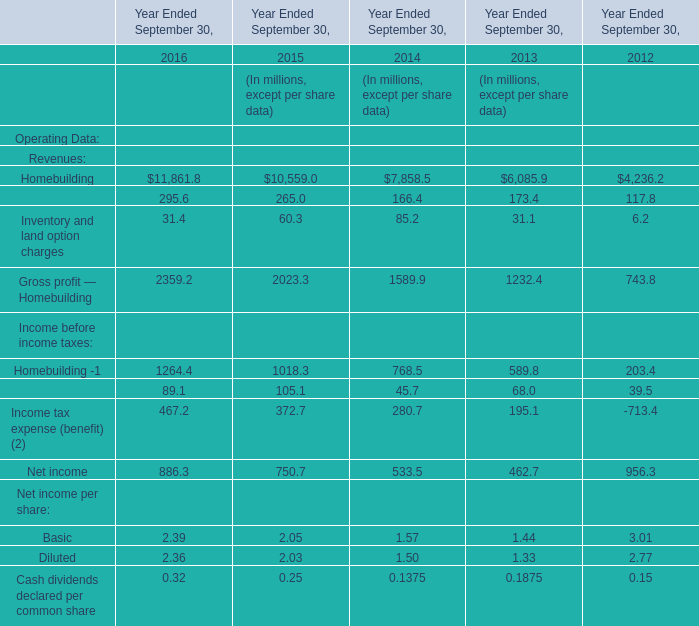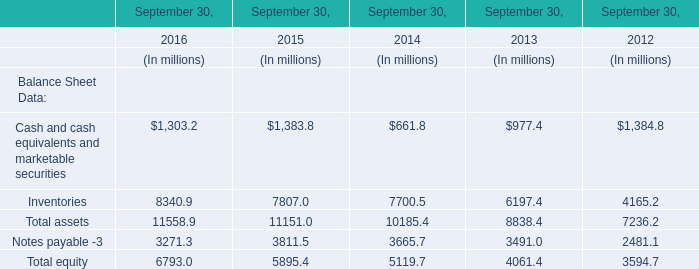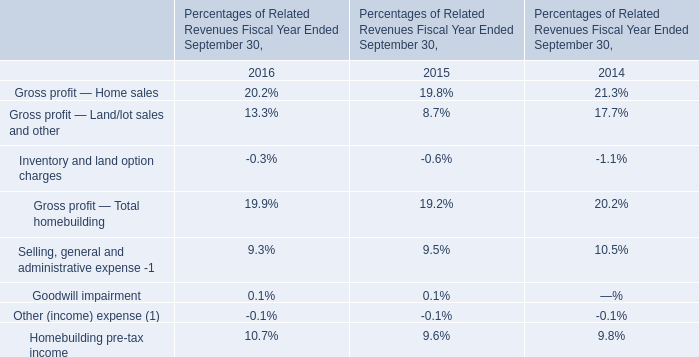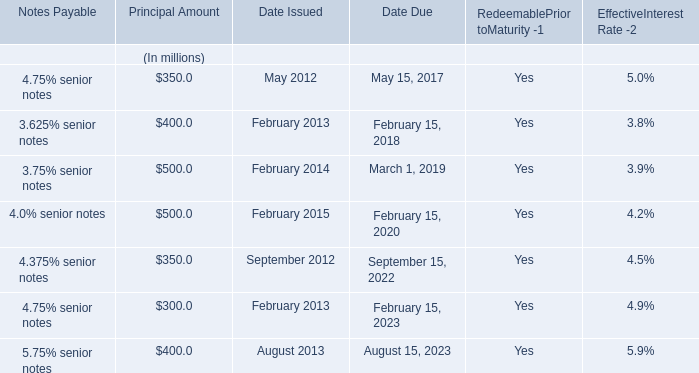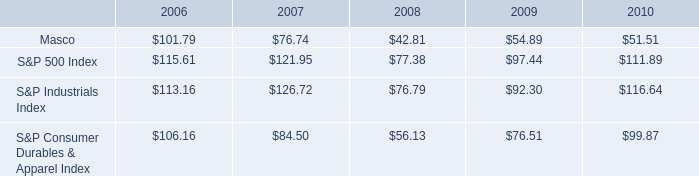What is the average value of Total equity in 2014, 2015, and 2016? (in million) 
Computations: (((6793.0 + 5895.4) + 5119.7) / 3)
Answer: 5936.03333. 